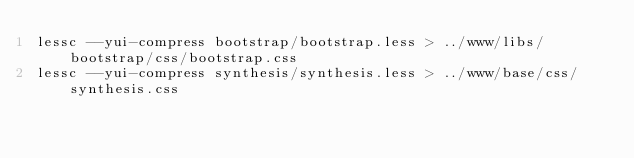<code> <loc_0><loc_0><loc_500><loc_500><_Bash_>lessc --yui-compress bootstrap/bootstrap.less > ../www/libs/bootstrap/css/bootstrap.css
lessc --yui-compress synthesis/synthesis.less > ../www/base/css/synthesis.css
</code> 